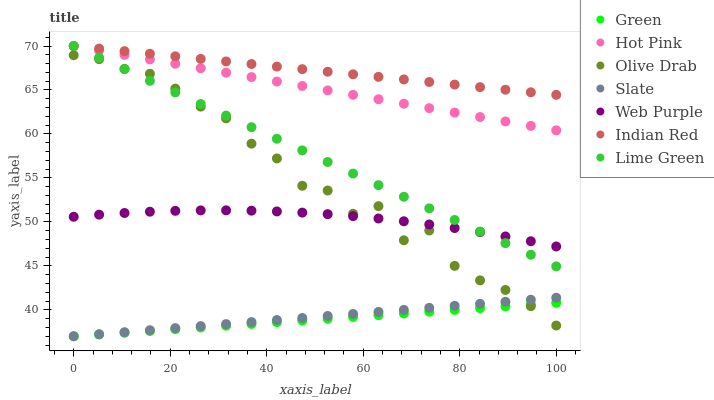Does Green have the minimum area under the curve?
Answer yes or no. Yes. Does Indian Red have the maximum area under the curve?
Answer yes or no. Yes. Does Hot Pink have the minimum area under the curve?
Answer yes or no. No. Does Hot Pink have the maximum area under the curve?
Answer yes or no. No. Is Green the smoothest?
Answer yes or no. Yes. Is Olive Drab the roughest?
Answer yes or no. Yes. Is Hot Pink the smoothest?
Answer yes or no. No. Is Hot Pink the roughest?
Answer yes or no. No. Does Slate have the lowest value?
Answer yes or no. Yes. Does Hot Pink have the lowest value?
Answer yes or no. No. Does Lime Green have the highest value?
Answer yes or no. Yes. Does Web Purple have the highest value?
Answer yes or no. No. Is Web Purple less than Indian Red?
Answer yes or no. Yes. Is Web Purple greater than Green?
Answer yes or no. Yes. Does Olive Drab intersect Web Purple?
Answer yes or no. Yes. Is Olive Drab less than Web Purple?
Answer yes or no. No. Is Olive Drab greater than Web Purple?
Answer yes or no. No. Does Web Purple intersect Indian Red?
Answer yes or no. No. 